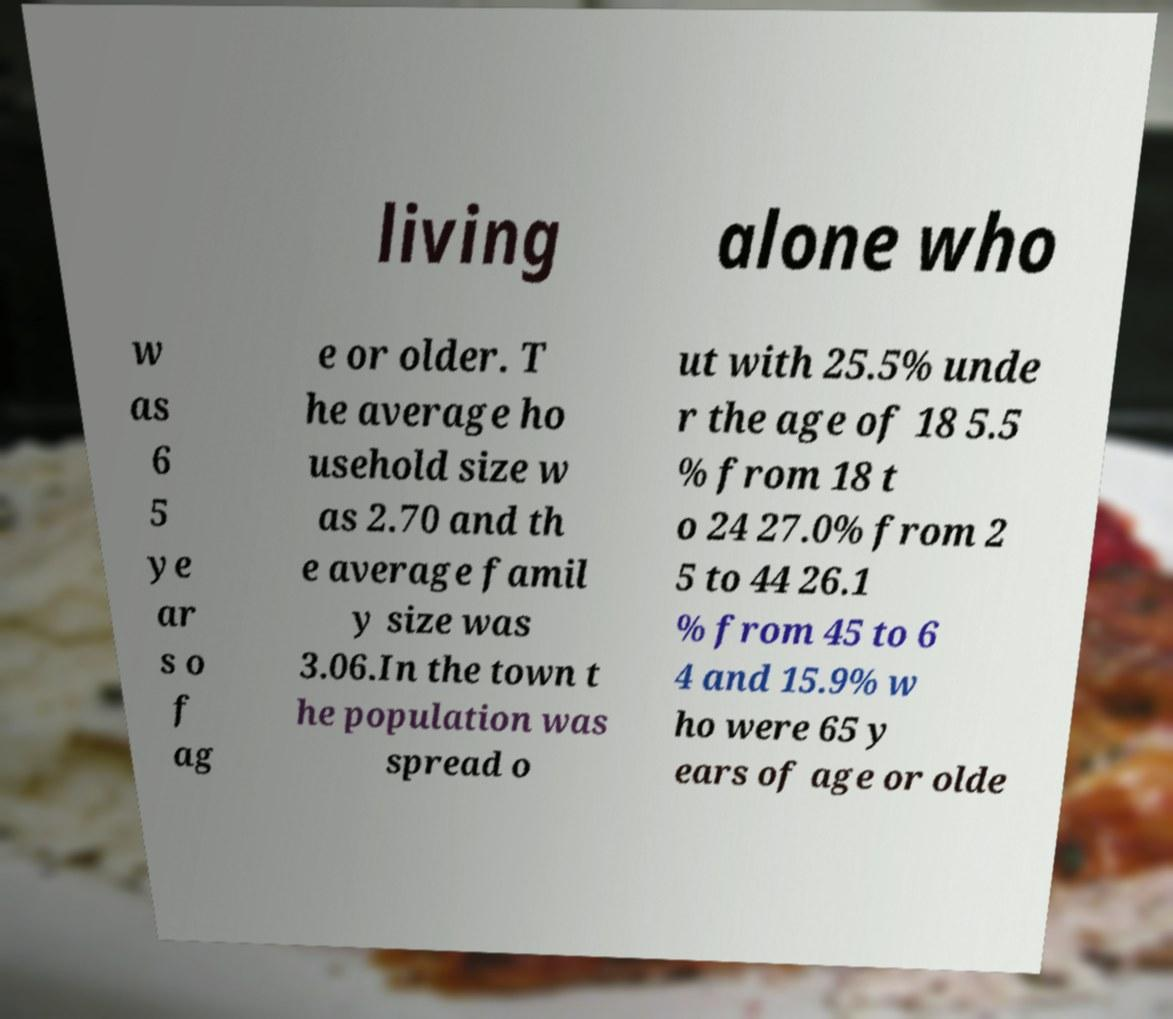For documentation purposes, I need the text within this image transcribed. Could you provide that? living alone who w as 6 5 ye ar s o f ag e or older. T he average ho usehold size w as 2.70 and th e average famil y size was 3.06.In the town t he population was spread o ut with 25.5% unde r the age of 18 5.5 % from 18 t o 24 27.0% from 2 5 to 44 26.1 % from 45 to 6 4 and 15.9% w ho were 65 y ears of age or olde 